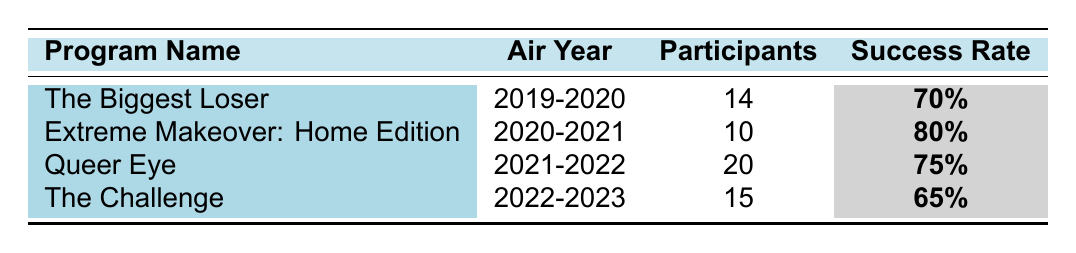What is the success rate of "Extreme Makeover: Home Edition"? The table shows that the success rate for "Extreme Makeover: Home Edition" is listed as 80%.
Answer: 80% How many participants were there in "Queer Eye"? The table indicates that "Queer Eye" had 20 participants.
Answer: 20 Which program had the highest success rate? By comparing the success rates, "Extreme Makeover: Home Edition" at 80% has the highest success rate among the listed programs.
Answer: Extreme Makeover: Home Edition What is the success rate of "The Challenge"? According to the table, the success rate for "The Challenge" is 65%.
Answer: 65% If you take the average success rate of all four programs, what is it? The success rates are 70%, 80%, 75%, and 65%. Adding them gives 70 + 80 + 75 + 65 = 290, then dividing by 4 results in an average of 290/4 = 72.5%.
Answer: 72.5% Is the success rate of "The Biggest Loser" higher than that of "The Challenge"? "The Biggest Loser" has a success rate of 70%, while "The Challenge" has a success rate of 65%. Therefore, the statement is true.
Answer: Yes What was the air year of the program with the lowest success rate? The program with the lowest success rate is "The Challenge" at 65%, which aired in 2022-2023.
Answer: 2022-2023 How many total participants were there across all programs? The participants from each program sum to: 14 + 10 + 20 + 15 = 59.
Answer: 59 Which program had the least number of participants? "Extreme Makeover: Home Edition" had the least number of participants, with a total of 10 participants.
Answer: Extreme Makeover: Home Edition Did "Queer Eye" have a higher success rate than "The Biggest Loser"? "Queer Eye" has a success rate of 75%, which is higher than "The Biggest Loser" at 70%. Thus, this statement is true.
Answer: Yes 